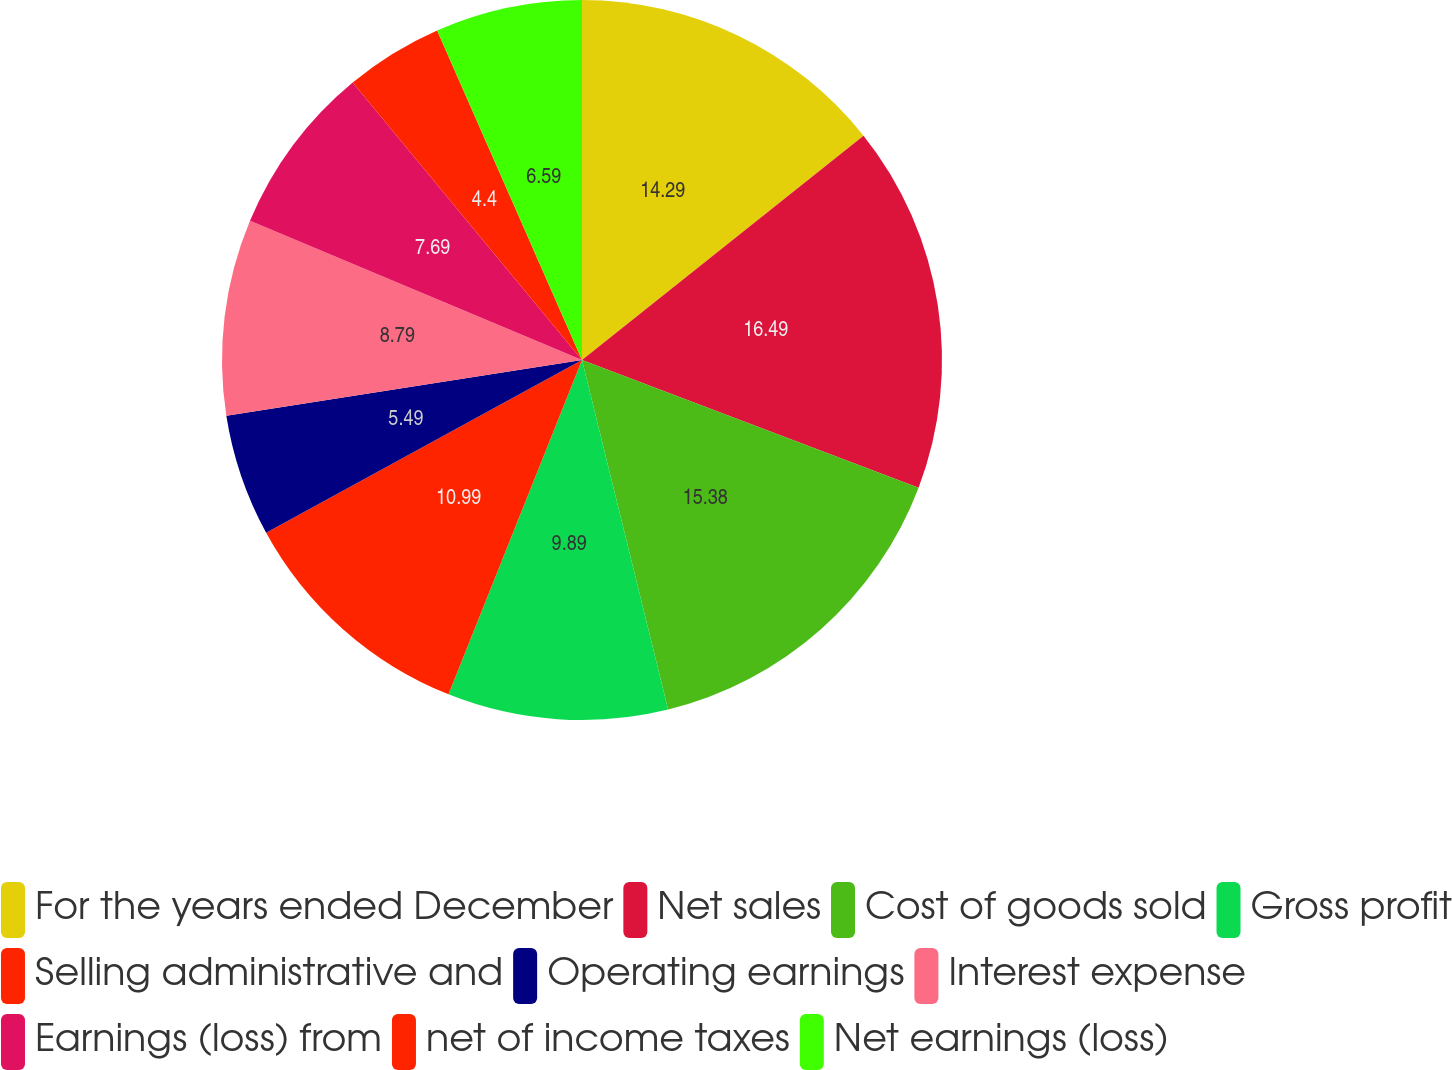Convert chart to OTSL. <chart><loc_0><loc_0><loc_500><loc_500><pie_chart><fcel>For the years ended December<fcel>Net sales<fcel>Cost of goods sold<fcel>Gross profit<fcel>Selling administrative and<fcel>Operating earnings<fcel>Interest expense<fcel>Earnings (loss) from<fcel>net of income taxes<fcel>Net earnings (loss)<nl><fcel>14.29%<fcel>16.48%<fcel>15.38%<fcel>9.89%<fcel>10.99%<fcel>5.49%<fcel>8.79%<fcel>7.69%<fcel>4.4%<fcel>6.59%<nl></chart> 